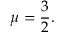<formula> <loc_0><loc_0><loc_500><loc_500>\mu = \frac { 3 } { 2 } .</formula> 